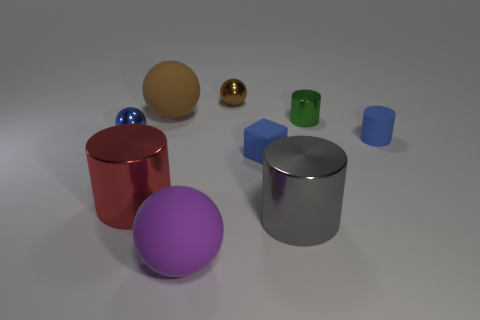Compare the sizes of the blue cube and the smaller blue cylinder. The smaller blue cylinder is definitely shorter in height compared to the blue cube. As for diameter, the cube's edge appears to be longer than the diameter of the cylinder, indicating that the blue cube is larger overall. Are those objects arranged in any specific pattern? The objects are not arranged in a clear pattern; they're placed seemingly at random across the surface. There is a mixture of shapes, colors, and sizes with no discernible sequence or symmetry. 